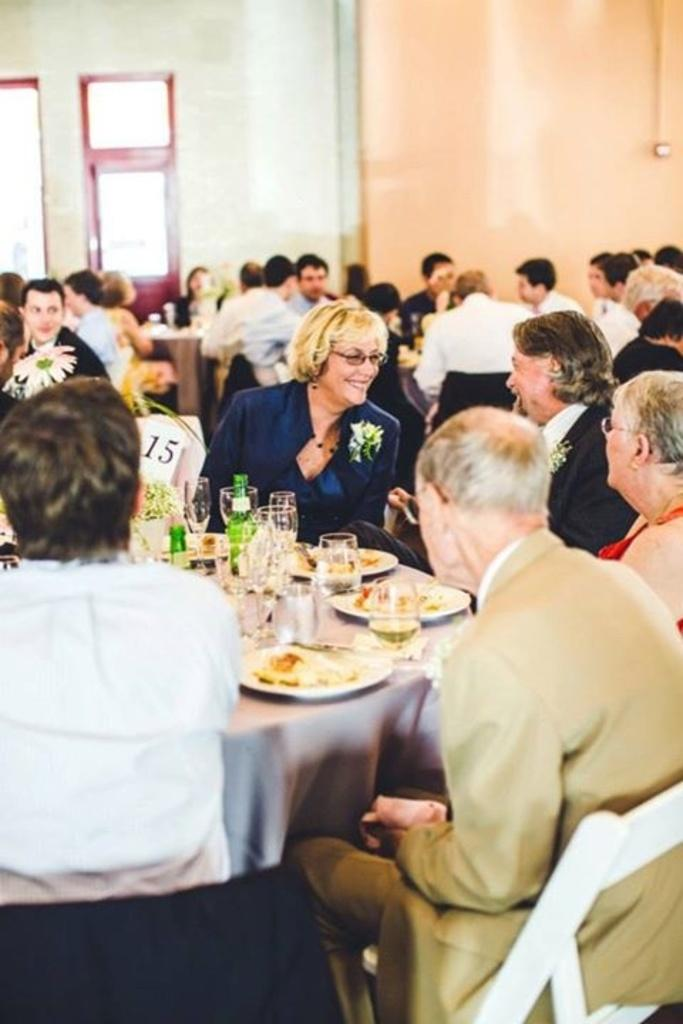What are the people in the image doing? There is a group of people sitting on chairs in the image. What is on the table in the image? There is a plate, food, a glass, a bottle, and a flower on the table in the image. Can you describe the background of the image? There is a wall, a window, and a door in the background of the image. How many ants can be seen crawling on the needle in the image? There is no needle or ants present in the image. What type of cave is visible in the background of the image? There is no cave present in the image; it features a wall, a window, and a door in the background. 